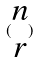<formula> <loc_0><loc_0><loc_500><loc_500>( \begin{matrix} n \\ r \end{matrix} )</formula> 